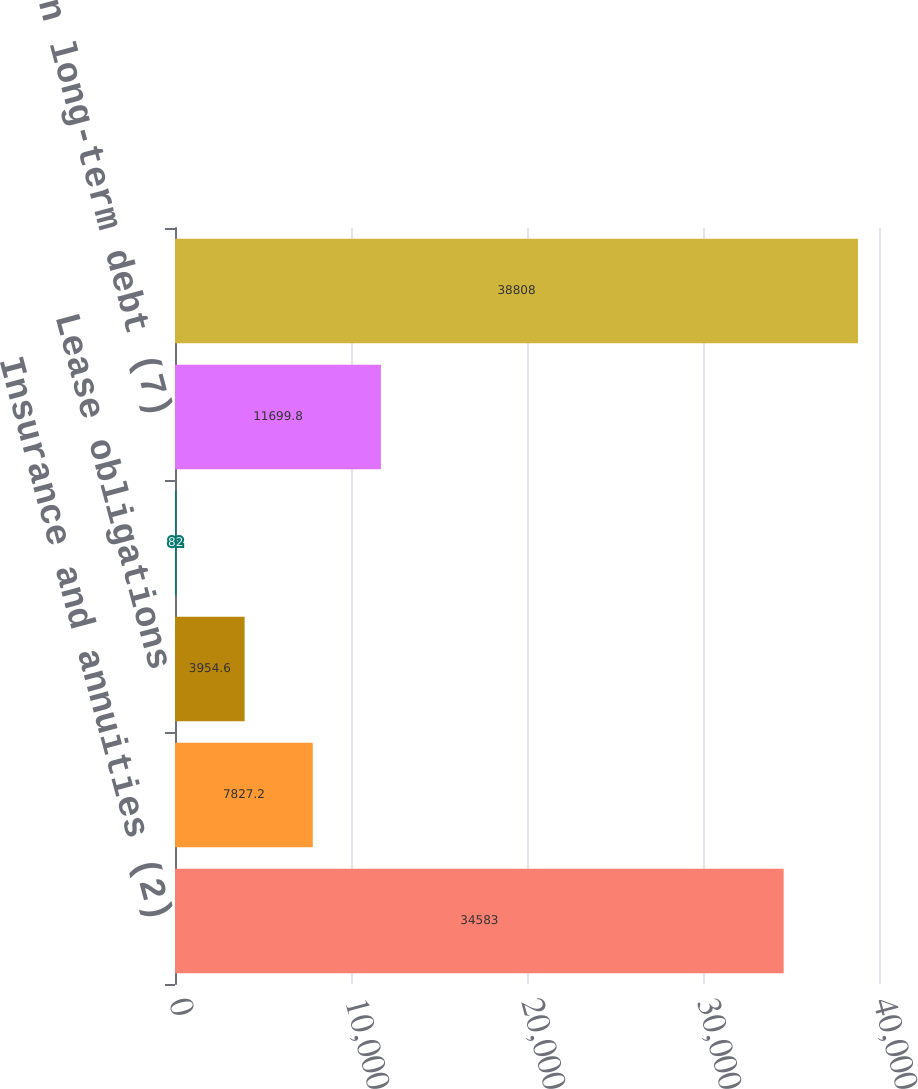<chart> <loc_0><loc_0><loc_500><loc_500><bar_chart><fcel>Insurance and annuities (2)<fcel>Deferred premium options (4)<fcel>Lease obligations<fcel>Purchase obligations (6)<fcel>Interest on long-term debt (7)<fcel>Total<nl><fcel>34583<fcel>7827.2<fcel>3954.6<fcel>82<fcel>11699.8<fcel>38808<nl></chart> 